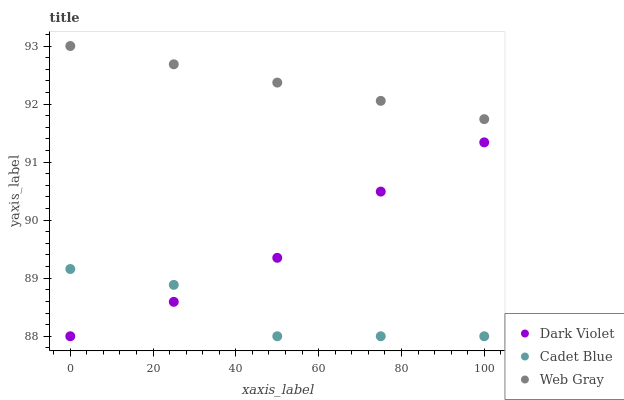Does Cadet Blue have the minimum area under the curve?
Answer yes or no. Yes. Does Web Gray have the maximum area under the curve?
Answer yes or no. Yes. Does Dark Violet have the minimum area under the curve?
Answer yes or no. No. Does Dark Violet have the maximum area under the curve?
Answer yes or no. No. Is Web Gray the smoothest?
Answer yes or no. Yes. Is Cadet Blue the roughest?
Answer yes or no. Yes. Is Dark Violet the smoothest?
Answer yes or no. No. Is Dark Violet the roughest?
Answer yes or no. No. Does Cadet Blue have the lowest value?
Answer yes or no. Yes. Does Web Gray have the lowest value?
Answer yes or no. No. Does Web Gray have the highest value?
Answer yes or no. Yes. Does Dark Violet have the highest value?
Answer yes or no. No. Is Dark Violet less than Web Gray?
Answer yes or no. Yes. Is Web Gray greater than Dark Violet?
Answer yes or no. Yes. Does Cadet Blue intersect Dark Violet?
Answer yes or no. Yes. Is Cadet Blue less than Dark Violet?
Answer yes or no. No. Is Cadet Blue greater than Dark Violet?
Answer yes or no. No. Does Dark Violet intersect Web Gray?
Answer yes or no. No. 